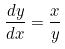Convert formula to latex. <formula><loc_0><loc_0><loc_500><loc_500>\frac { d y } { d x } = \frac { x } { y }</formula> 